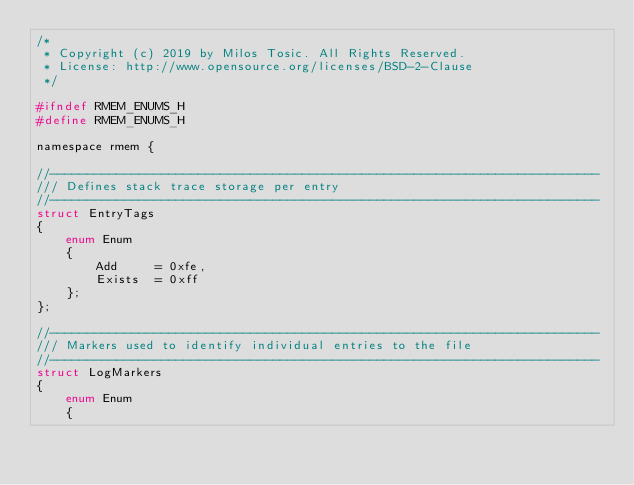Convert code to text. <code><loc_0><loc_0><loc_500><loc_500><_C_>/*
 * Copyright (c) 2019 by Milos Tosic. All Rights Reserved.
 * License: http://www.opensource.org/licenses/BSD-2-Clause
 */

#ifndef RMEM_ENUMS_H
#define RMEM_ENUMS_H

namespace rmem {

//--------------------------------------------------------------------------
/// Defines stack trace storage per entry
//--------------------------------------------------------------------------
struct EntryTags
{
	enum Enum
	{
		Add		= 0xfe,
		Exists	= 0xff
	};
};

//--------------------------------------------------------------------------
/// Markers used to identify individual entries to the file
//--------------------------------------------------------------------------
struct LogMarkers
{
	enum Enum
	{</code> 